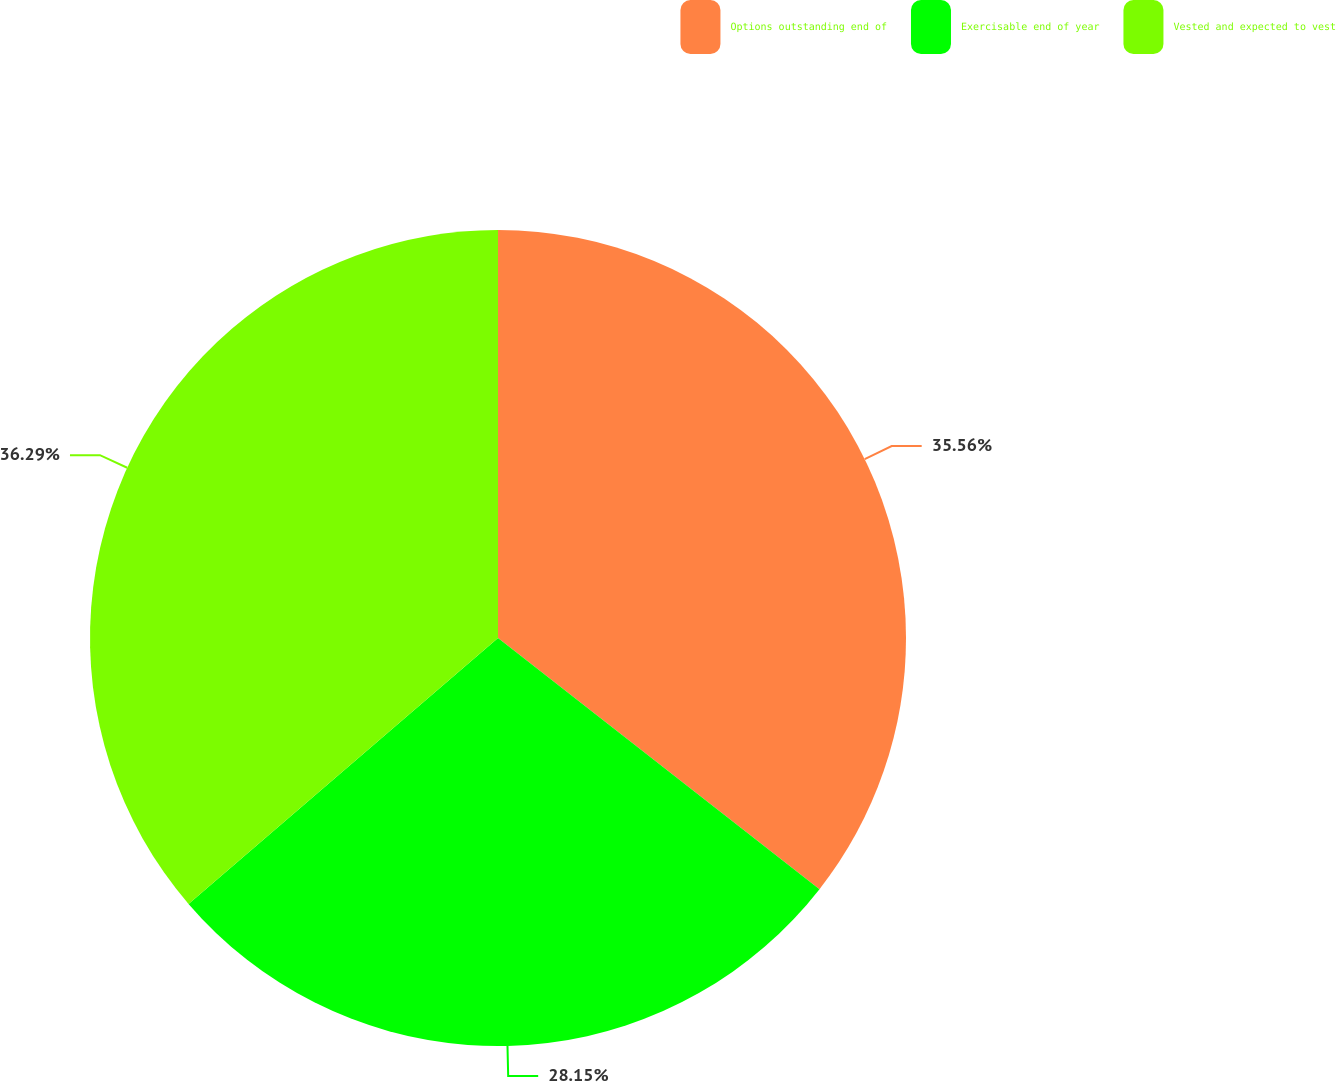<chart> <loc_0><loc_0><loc_500><loc_500><pie_chart><fcel>Options outstanding end of<fcel>Exercisable end of year<fcel>Vested and expected to vest<nl><fcel>35.56%<fcel>28.15%<fcel>36.3%<nl></chart> 